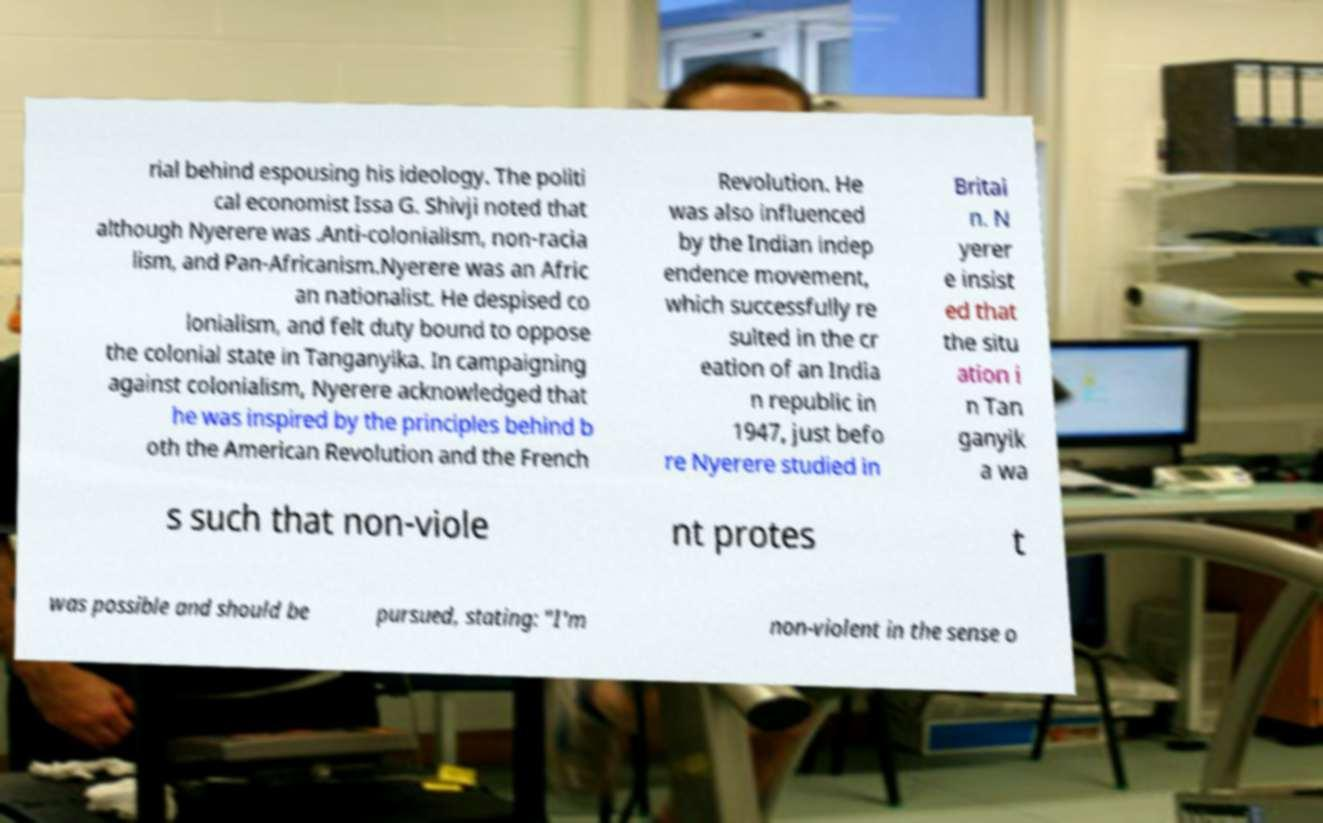I need the written content from this picture converted into text. Can you do that? rial behind espousing his ideology. The politi cal economist Issa G. Shivji noted that although Nyerere was .Anti-colonialism, non-racia lism, and Pan-Africanism.Nyerere was an Afric an nationalist. He despised co lonialism, and felt duty bound to oppose the colonial state in Tanganyika. In campaigning against colonialism, Nyerere acknowledged that he was inspired by the principles behind b oth the American Revolution and the French Revolution. He was also influenced by the Indian indep endence movement, which successfully re sulted in the cr eation of an India n republic in 1947, just befo re Nyerere studied in Britai n. N yerer e insist ed that the situ ation i n Tan ganyik a wa s such that non-viole nt protes t was possible and should be pursued, stating: "I'm non-violent in the sense o 